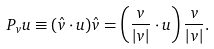Convert formula to latex. <formula><loc_0><loc_0><loc_500><loc_500>P _ { v } u \equiv ( \hat { v } \cdot u ) \hat { v } = \left ( \frac { v } { | v | } \cdot u \right ) \frac { v } { | v | } .</formula> 